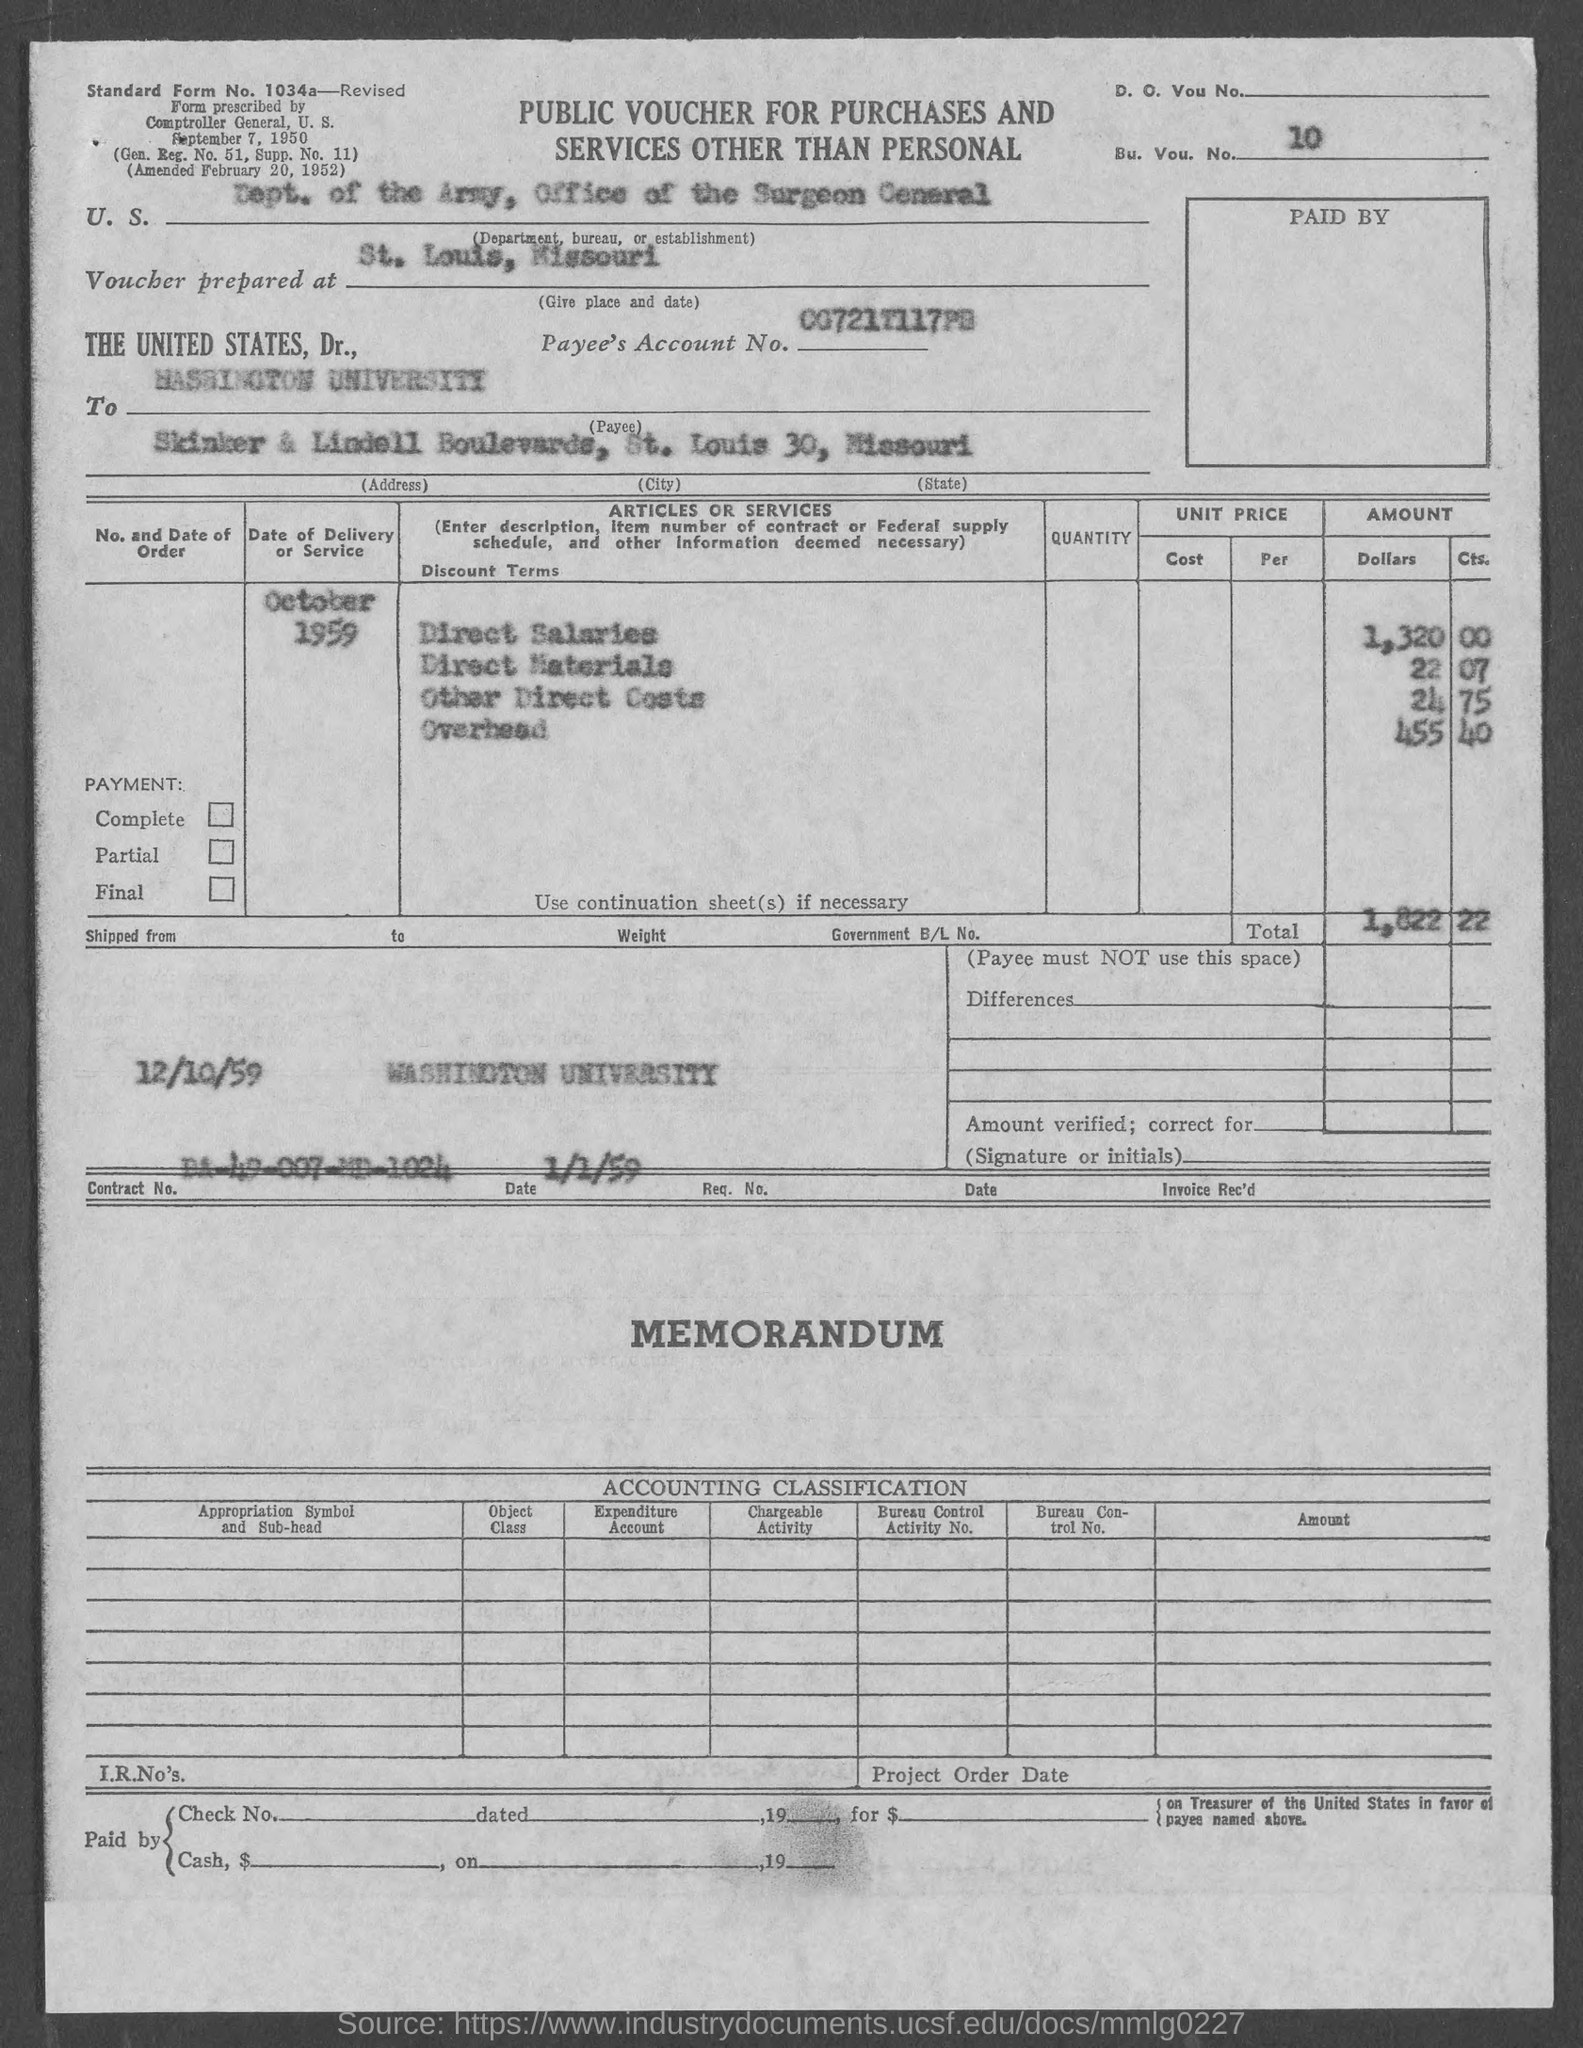Give some essential details in this illustration. The payee state is Missouri. The amount for other Direct costs is $24 and the amount for the 75% indirect cost rate is $17. The payee is Washington University. The voucher is being prepared for St. Louis, Missouri. The overhead amount is 455. 